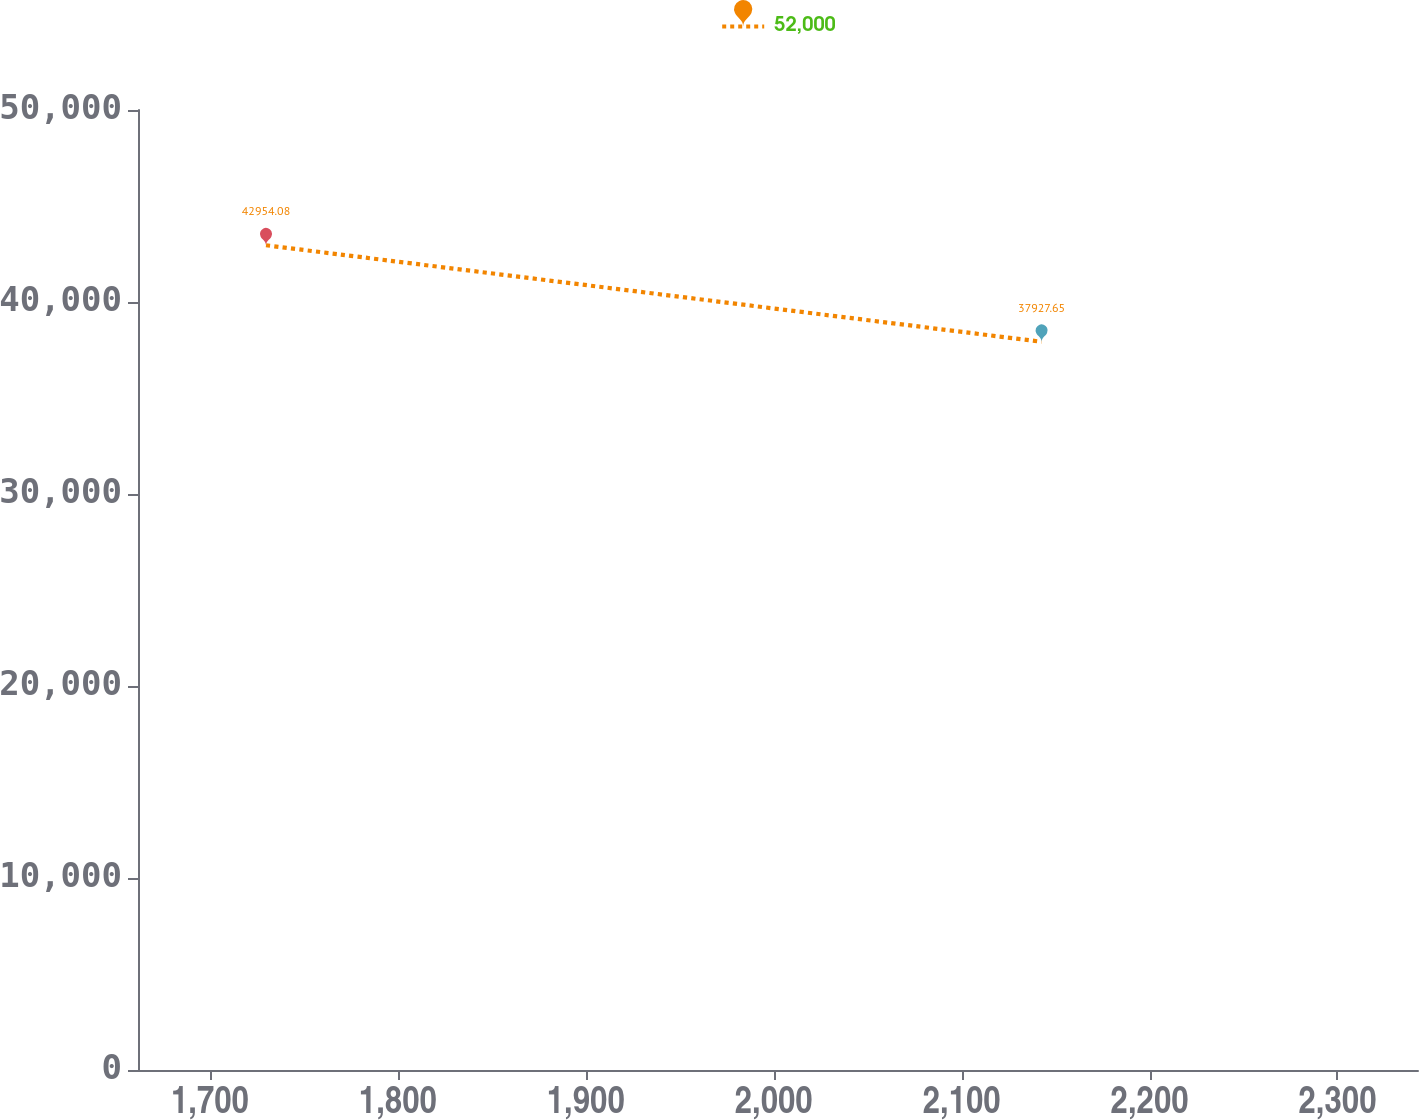Convert chart to OTSL. <chart><loc_0><loc_0><loc_500><loc_500><line_chart><ecel><fcel>52,000<nl><fcel>1729.84<fcel>42954.1<nl><fcel>2142.57<fcel>37927.7<nl><fcel>2410.96<fcel>41305.1<nl></chart> 